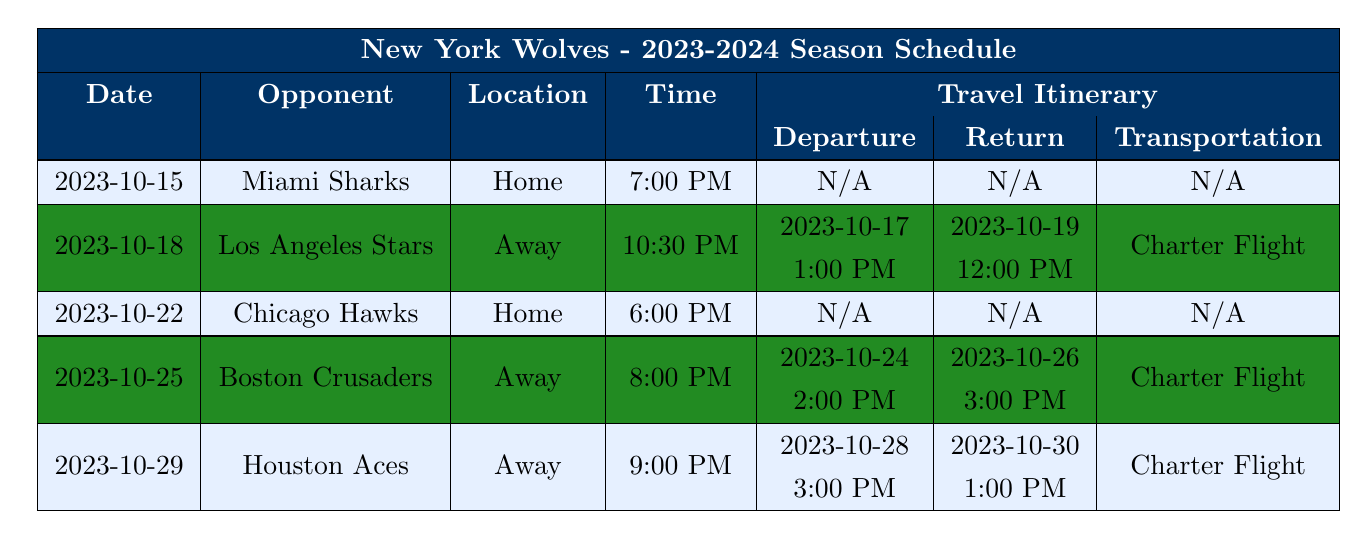What is the date of the game against the Miami Sharks? The table lists the date for each opponent, and for the Miami Sharks, it shows 2023-10-15.
Answer: 2023-10-15 How many away games does the New York Wolves have in October? The table has four games listed, and three of them (Los Angeles Stars, Boston Crusaders, and Houston Aces) are specified as away games.
Answer: 3 What time is the game against the Chicago Hawks? The table indicates the time for each game, and the game against the Chicago Hawks is scheduled for 6:00 PM.
Answer: 6:00 PM Is there a travel itinerary for the game against the Miami Sharks? The table shows that for the Miami Sharks game, the travel itinerary is marked as N/A, indicating no travel involved.
Answer: No What is the transportation method for the game against the Boston Crusaders? The table states the transportation method for the Boston Crusaders game is a Charter Flight.
Answer: Charter Flight What is the earliest game in the table? By comparing the dates listed in the table, the earliest game is against the Miami Sharks on 2023-10-15.
Answer: 2023-10-15 What is the total number of games listed in the schedule for October? The table lists five games in October, specifically from October 15 to October 29.
Answer: 5 What is the departure time for the away game against the Houston Aces? The travel itinerary for the Houston Aces game shows the departure time is set for 3:00 PM on 2023-10-28.
Answer: 3:00 PM Which team do the New York Wolves play at home on October 22? The schedule specifies the Wolves will face the Chicago Hawks at home on October 22.
Answer: Chicago Hawks Are all away games scheduled after home games? Reviewing the schedule reveals the Los Angeles Stars game (away) is follows the Miami Sharks game (home), then the Boston Crusaders (away) follows a home game, confirming the pattern.
Answer: Yes What is the return date after the game against Los Angeles Stars? The return date from the away game against the Los Angeles Stars is 2023-10-19, as per the itinerary in the table.
Answer: 2023-10-19 Overall, how many home games does the New York Wolves play in October? By examining the table, it shows there are two home games, one against the Miami Sharks and one against the Chicago Hawks.
Answer: 2 What will be the last game played by the New York Wolves in October? The last game listed for October is against the Houston Aces on October 29.
Answer: October 29 What is the difference in time for the departure and return for the Boston Crusaders away game? The departure is at 2:00 PM and the return is at 3:00 PM. The difference between these two times is 1 hour.
Answer: 1 hour Which opponent has a scheduled game at 10:30 PM? The table indicates that the game against the Los Angeles Stars is scheduled for 10:30 PM.
Answer: Los Angeles Stars How many total away games take place before October 25? The only away game before October 25 is against the Los Angeles Stars on October 18.
Answer: 1 